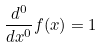Convert formula to latex. <formula><loc_0><loc_0><loc_500><loc_500>\frac { d ^ { 0 } } { d x ^ { 0 } } f ( x ) = 1</formula> 